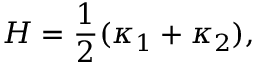Convert formula to latex. <formula><loc_0><loc_0><loc_500><loc_500>H = \frac { 1 } { 2 } ( \kappa _ { 1 } + \kappa _ { 2 } ) ,</formula> 